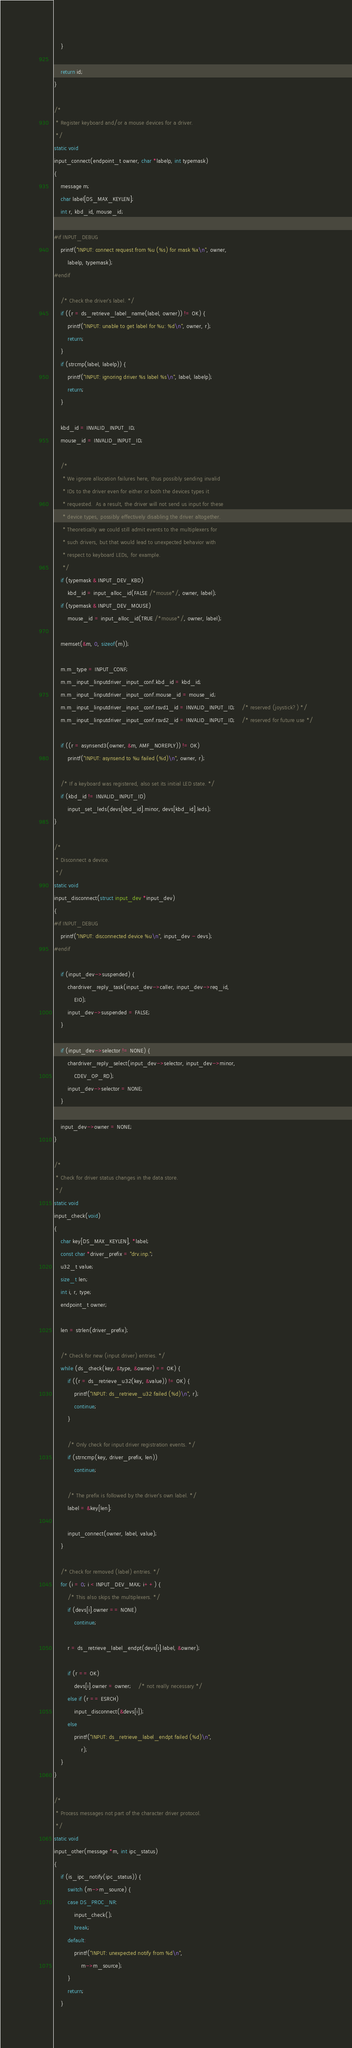<code> <loc_0><loc_0><loc_500><loc_500><_C_>	}

	return id;
}

/*
 * Register keyboard and/or a mouse devices for a driver.
 */
static void
input_connect(endpoint_t owner, char *labelp, int typemask)
{
	message m;
	char label[DS_MAX_KEYLEN];
	int r, kbd_id, mouse_id;

#if INPUT_DEBUG
	printf("INPUT: connect request from %u (%s) for mask %x\n", owner,
	    labelp, typemask);
#endif

	/* Check the driver's label. */
	if ((r = ds_retrieve_label_name(label, owner)) != OK) {
		printf("INPUT: unable to get label for %u: %d\n", owner, r);
		return;
	}
	if (strcmp(label, labelp)) {
		printf("INPUT: ignoring driver %s label %s\n", label, labelp);
		return;
	}

	kbd_id = INVALID_INPUT_ID;
	mouse_id = INVALID_INPUT_ID;

	/*
	 * We ignore allocation failures here, thus possibly sending invalid
	 * IDs to the driver even for either or both the devices types it
	 * requested.  As a result, the driver will not send us input for these
	 * device types, possibly effectively disabling the driver altogether.
	 * Theoretically we could still admit events to the multiplexers for
	 * such drivers, but that would lead to unexpected behavior with
	 * respect to keyboard LEDs, for example.
	 */
	if (typemask & INPUT_DEV_KBD)
		kbd_id = input_alloc_id(FALSE /*mouse*/, owner, label);
	if (typemask & INPUT_DEV_MOUSE)
		mouse_id = input_alloc_id(TRUE /*mouse*/, owner, label);

	memset(&m, 0, sizeof(m));

	m.m_type = INPUT_CONF;
	m.m_input_linputdriver_input_conf.kbd_id = kbd_id;
	m.m_input_linputdriver_input_conf.mouse_id = mouse_id;
	m.m_input_linputdriver_input_conf.rsvd1_id = INVALID_INPUT_ID;	/* reserved (joystick?) */
	m.m_input_linputdriver_input_conf.rsvd2_id = INVALID_INPUT_ID;	/* reserved for future use */

	if ((r = asynsend3(owner, &m, AMF_NOREPLY)) != OK)
		printf("INPUT: asynsend to %u failed (%d)\n", owner, r);

	/* If a keyboard was registered, also set its initial LED state. */
	if (kbd_id != INVALID_INPUT_ID)
		input_set_leds(devs[kbd_id].minor, devs[kbd_id].leds);
}

/*
 * Disconnect a device.
 */
static void
input_disconnect(struct input_dev *input_dev)
{
#if INPUT_DEBUG
	printf("INPUT: disconnected device %u\n", input_dev - devs);
#endif

	if (input_dev->suspended) {
		chardriver_reply_task(input_dev->caller, input_dev->req_id,
		    EIO);
		input_dev->suspended = FALSE;
	}

	if (input_dev->selector != NONE) {
		chardriver_reply_select(input_dev->selector, input_dev->minor,
		    CDEV_OP_RD);
		input_dev->selector = NONE;
	}

	input_dev->owner = NONE;
}

/*
 * Check for driver status changes in the data store.
 */
static void
input_check(void)
{
	char key[DS_MAX_KEYLEN], *label;
	const char *driver_prefix = "drv.inp.";
	u32_t value;
	size_t len;
	int i, r, type;
	endpoint_t owner;

	len = strlen(driver_prefix);

	/* Check for new (input driver) entries. */
	while (ds_check(key, &type, &owner) == OK) {
		if ((r = ds_retrieve_u32(key, &value)) != OK) {
			printf("INPUT: ds_retrieve_u32 failed (%d)\n", r);
			continue;
		}

		/* Only check for input driver registration events. */
		if (strncmp(key, driver_prefix, len))
			continue;

		/* The prefix is followed by the driver's own label. */
		label = &key[len];

		input_connect(owner, label, value);
	}

	/* Check for removed (label) entries. */
	for (i = 0; i < INPUT_DEV_MAX; i++) {
		/* This also skips the multiplexers. */
		if (devs[i].owner == NONE)
			continue;

		r = ds_retrieve_label_endpt(devs[i].label, &owner);

		if (r == OK)
			devs[i].owner = owner;	/* not really necessary */
		else if (r == ESRCH)
			input_disconnect(&devs[i]);
		else
			printf("INPUT: ds_retrieve_label_endpt failed (%d)\n",
			    r);
	}
}

/*
 * Process messages not part of the character driver protocol.
 */
static void
input_other(message *m, int ipc_status)
{
	if (is_ipc_notify(ipc_status)) {
		switch (m->m_source) {
		case DS_PROC_NR:
			input_check();
			break;
		default:
			printf("INPUT: unexpected notify from %d\n",
			    m->m_source);
		}
		return;
	}
</code> 